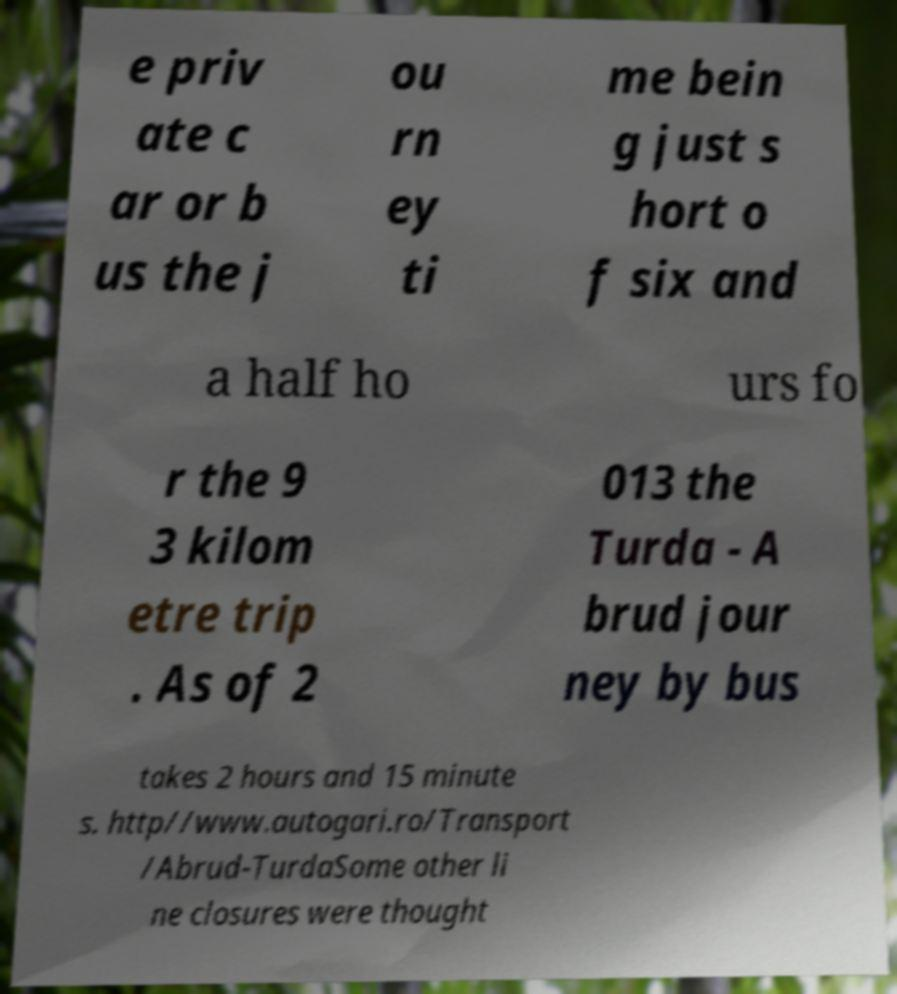Please read and relay the text visible in this image. What does it say? e priv ate c ar or b us the j ou rn ey ti me bein g just s hort o f six and a half ho urs fo r the 9 3 kilom etre trip . As of 2 013 the Turda - A brud jour ney by bus takes 2 hours and 15 minute s. http//www.autogari.ro/Transport /Abrud-TurdaSome other li ne closures were thought 